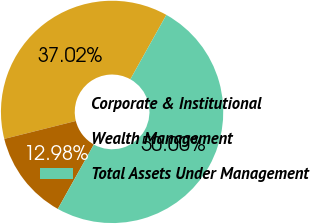<chart> <loc_0><loc_0><loc_500><loc_500><pie_chart><fcel>Corporate & Institutional<fcel>Wealth Management<fcel>Total Assets Under Management<nl><fcel>37.02%<fcel>12.98%<fcel>50.0%<nl></chart> 